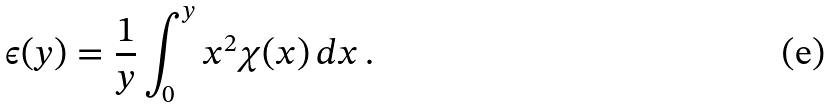Convert formula to latex. <formula><loc_0><loc_0><loc_500><loc_500>\epsilon ( y ) = \frac { 1 } { y } \int _ { 0 } ^ { y } x ^ { 2 } \chi ( x ) \, d x \, .</formula> 